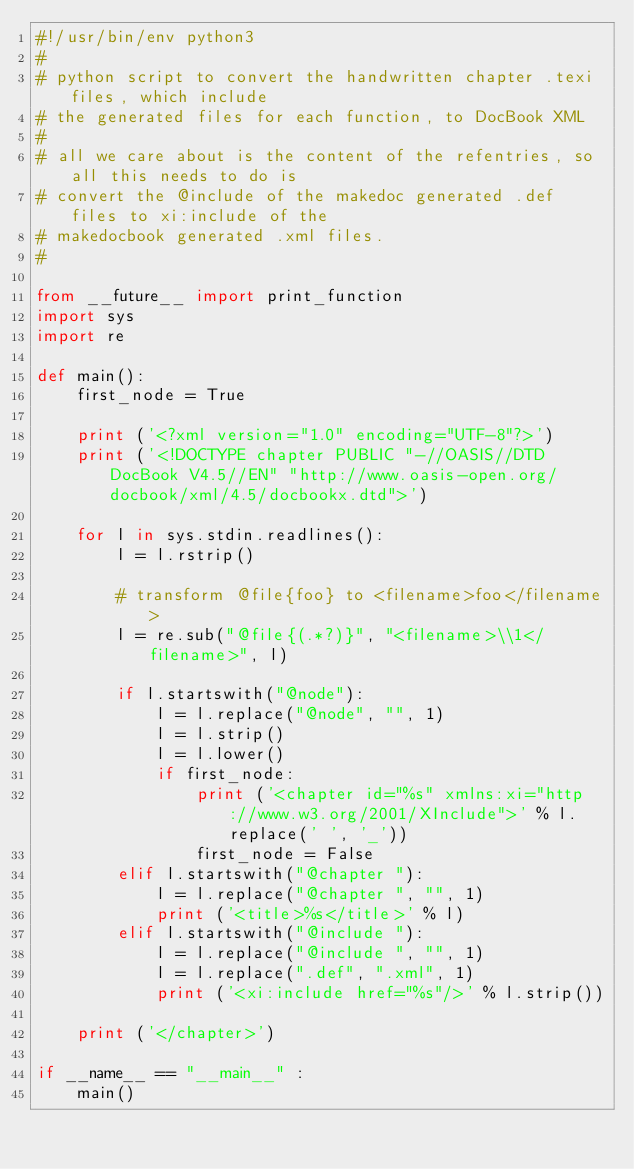<code> <loc_0><loc_0><loc_500><loc_500><_Python_>#!/usr/bin/env python3
#
# python script to convert the handwritten chapter .texi files, which include
# the generated files for each function, to DocBook XML
#
# all we care about is the content of the refentries, so all this needs to do is
# convert the @include of the makedoc generated .def files to xi:include of the
# makedocbook generated .xml files.
#

from __future__ import print_function
import sys
import re

def main():
    first_node = True

    print ('<?xml version="1.0" encoding="UTF-8"?>')
    print ('<!DOCTYPE chapter PUBLIC "-//OASIS//DTD DocBook V4.5//EN" "http://www.oasis-open.org/docbook/xml/4.5/docbookx.dtd">')

    for l in sys.stdin.readlines():
        l = l.rstrip()

        # transform @file{foo} to <filename>foo</filename>
        l = re.sub("@file{(.*?)}", "<filename>\\1</filename>", l)

        if l.startswith("@node"):
            l = l.replace("@node", "", 1)
            l = l.strip()
            l = l.lower()
            if first_node:
                print ('<chapter id="%s" xmlns:xi="http://www.w3.org/2001/XInclude">' % l.replace(' ', '_'))
                first_node = False
        elif l.startswith("@chapter "):
            l = l.replace("@chapter ", "", 1)
            print ('<title>%s</title>' % l)
        elif l.startswith("@include "):
            l = l.replace("@include ", "", 1)
            l = l.replace(".def", ".xml", 1)
            print ('<xi:include href="%s"/>' % l.strip())

    print ('</chapter>')

if __name__ == "__main__" :
    main()
</code> 